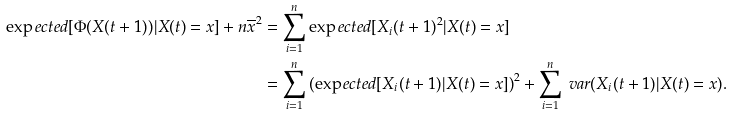<formula> <loc_0><loc_0><loc_500><loc_500>\exp e c t e d [ \Phi ( X ( t + 1 ) ) | X ( t ) = x ] + n \overline { x } ^ { 2 } & = \sum _ { i = 1 } ^ { n } \exp e c t e d [ X _ { i } ( t + 1 ) ^ { 2 } | X ( t ) = x ] \\ & = \sum _ { i = 1 } ^ { n } { ( \exp e c t e d [ X _ { i } ( t + 1 ) | X ( t ) = x ] ) } ^ { 2 } + \sum _ { i = 1 } ^ { n } \ v a r ( X _ { i } ( t + 1 ) | X ( t ) = x ) .</formula> 